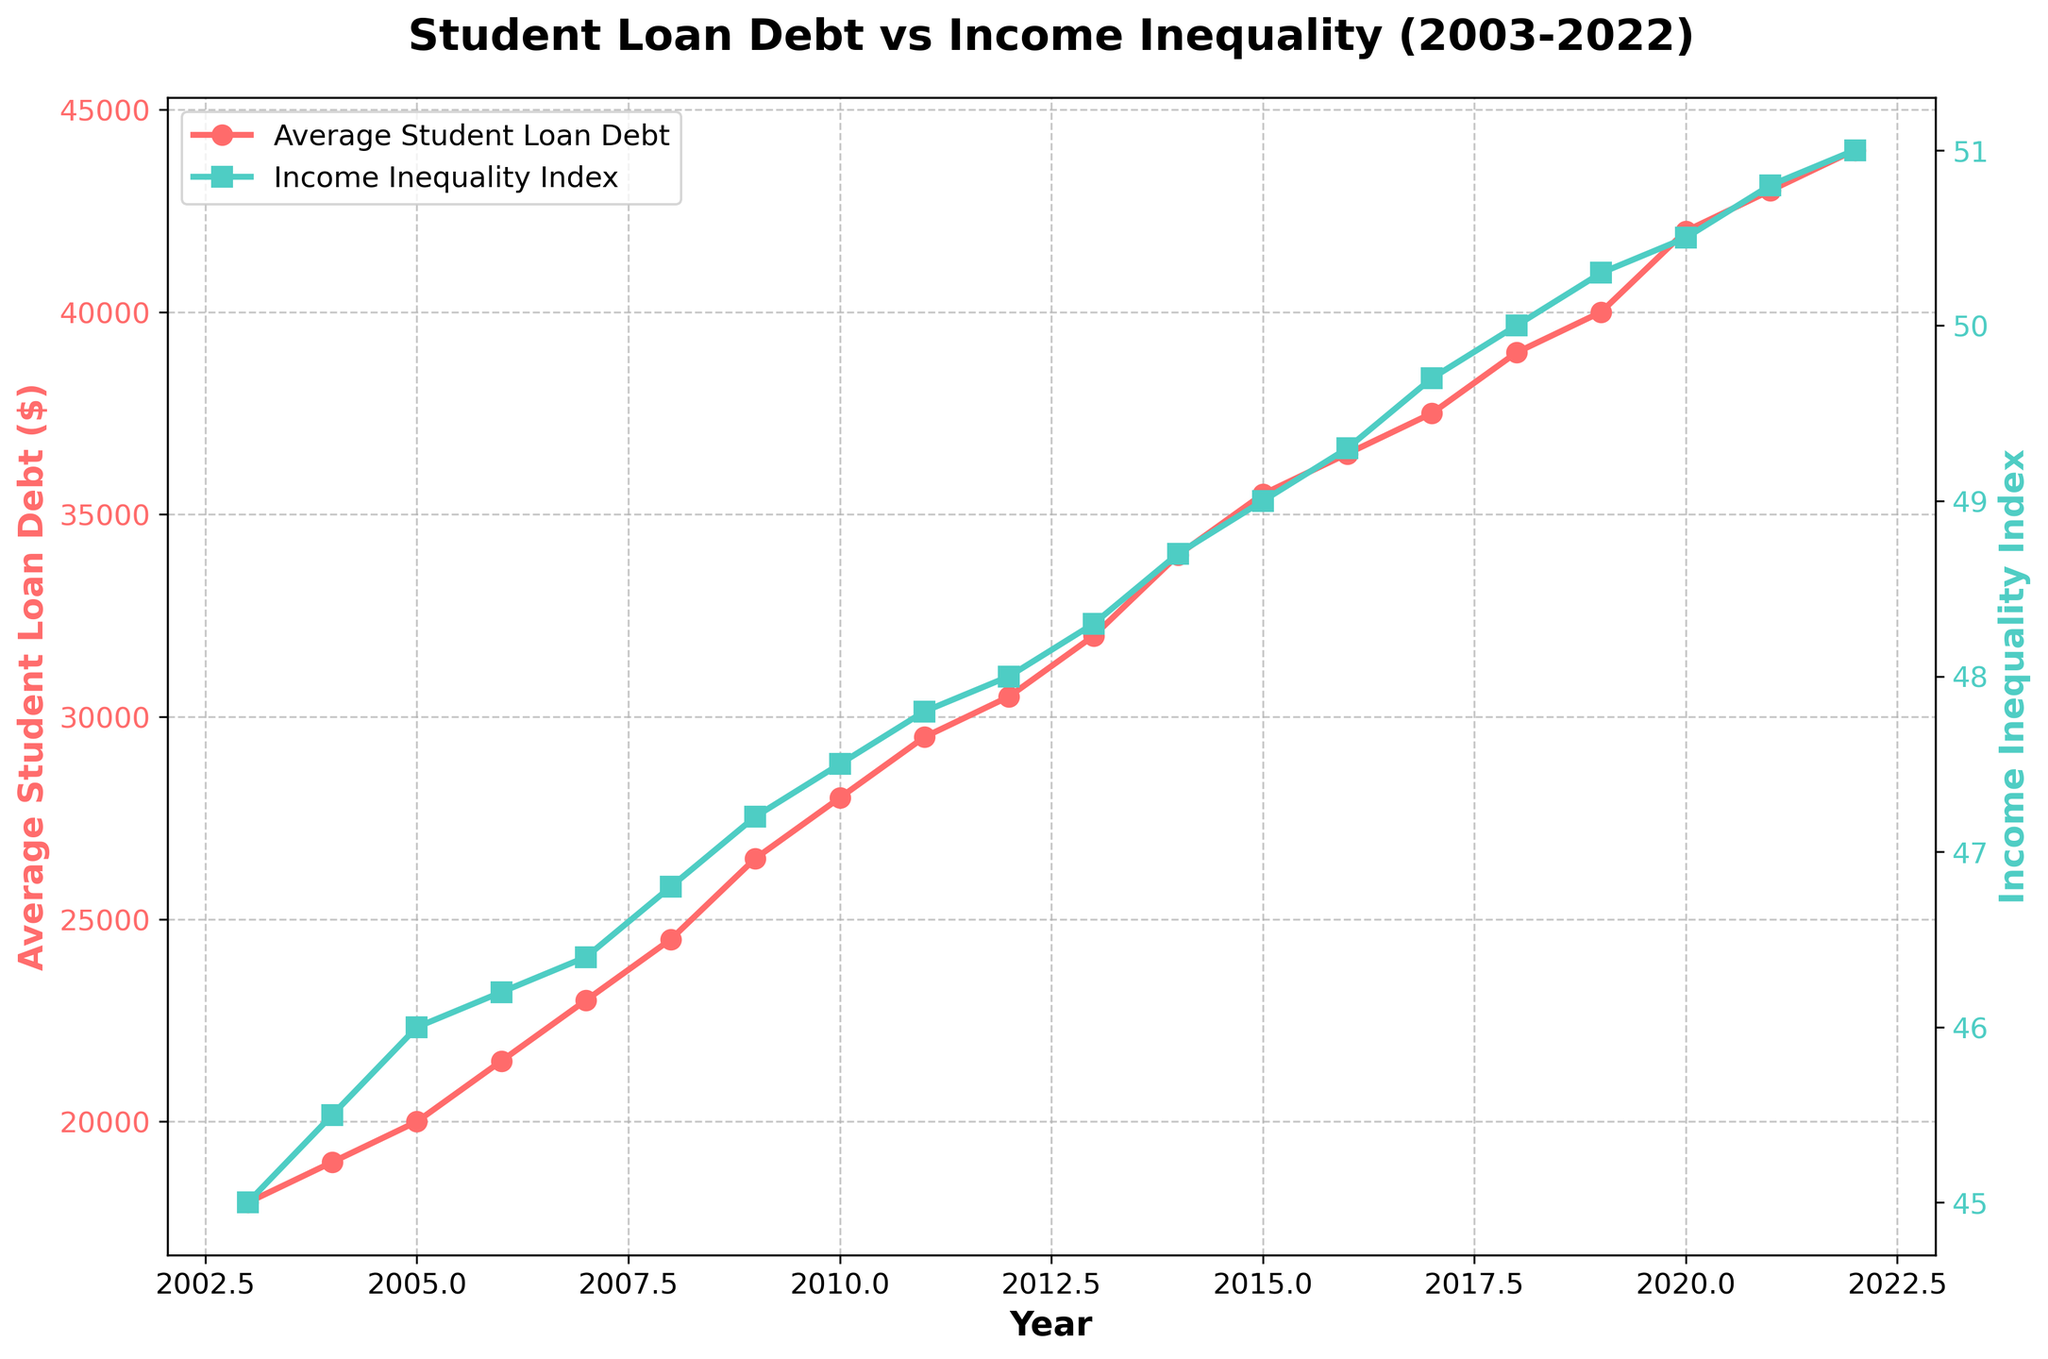What is the title of the plot? The title of the plot is typically located at the top center of the figure. From the provided description, the title is "Student Loan Debt vs Income Inequality (2003-2022)."
Answer: Student Loan Debt vs Income Inequality (2003-2022) Which year had the highest average student loan debt? To identify the year with the highest average student loan debt, look for the peak point in the red line (representing Average Student Loan Debt) on the plot. The peak appears to be in 2022 at $44,000.
Answer: 2022 What trend can you observe in the Income Inequality Index from 2003 to 2022? The green line representing the Income Inequality Index shows an upward trajectory from 2003 to 2022, indicating that income inequality has been increasing over this period.
Answer: Increasing By how much did the Average Student Loan Debt increase from 2003 to 2022? The average student loan debt in 2003 was $18,000, and in 2022 it was $44,000. The increase is calculated by subtracting the 2003 value from the 2022 value: $44,000 - $18,000 = $26,000.
Answer: $26,000 Which year experienced the smallest increase in the Income Inequality Index compared to the previous year? To find the smallest increase, examine the green line and the corresponding values for the smallest year-over-year increments. Between 2003 and 2022, the difference between 2005 (46.0) and 2004 (45.5) is the smallest increment at 0.5.
Answer: 2005 How does the trend of the Gini Coefficient compare to the trend of the Average Student Loan Debt from 2003 to 2022? Both the Gini Coefficient and the Average Student Loan Debt show consistent upward trends from 2003 to 2022, indicating that both income inequality and student loan debt have increased over this time period.
Answer: Both are increasing In which year did the Average Student Loan Debt reach $30,000? To find when the average student loan debt reached $30,000, look for the point where the red line touched or exceeded $30,000. This happens around 2012.
Answer: 2012 What is the difference in the Income Inequality Index between 2022 and 2003? The Income Inequality Index in 2022 is 51.0, while in 2003 it was 45.0. The difference is calculated as 51.0 - 45.0 = 6.0.
Answer: 6.0 